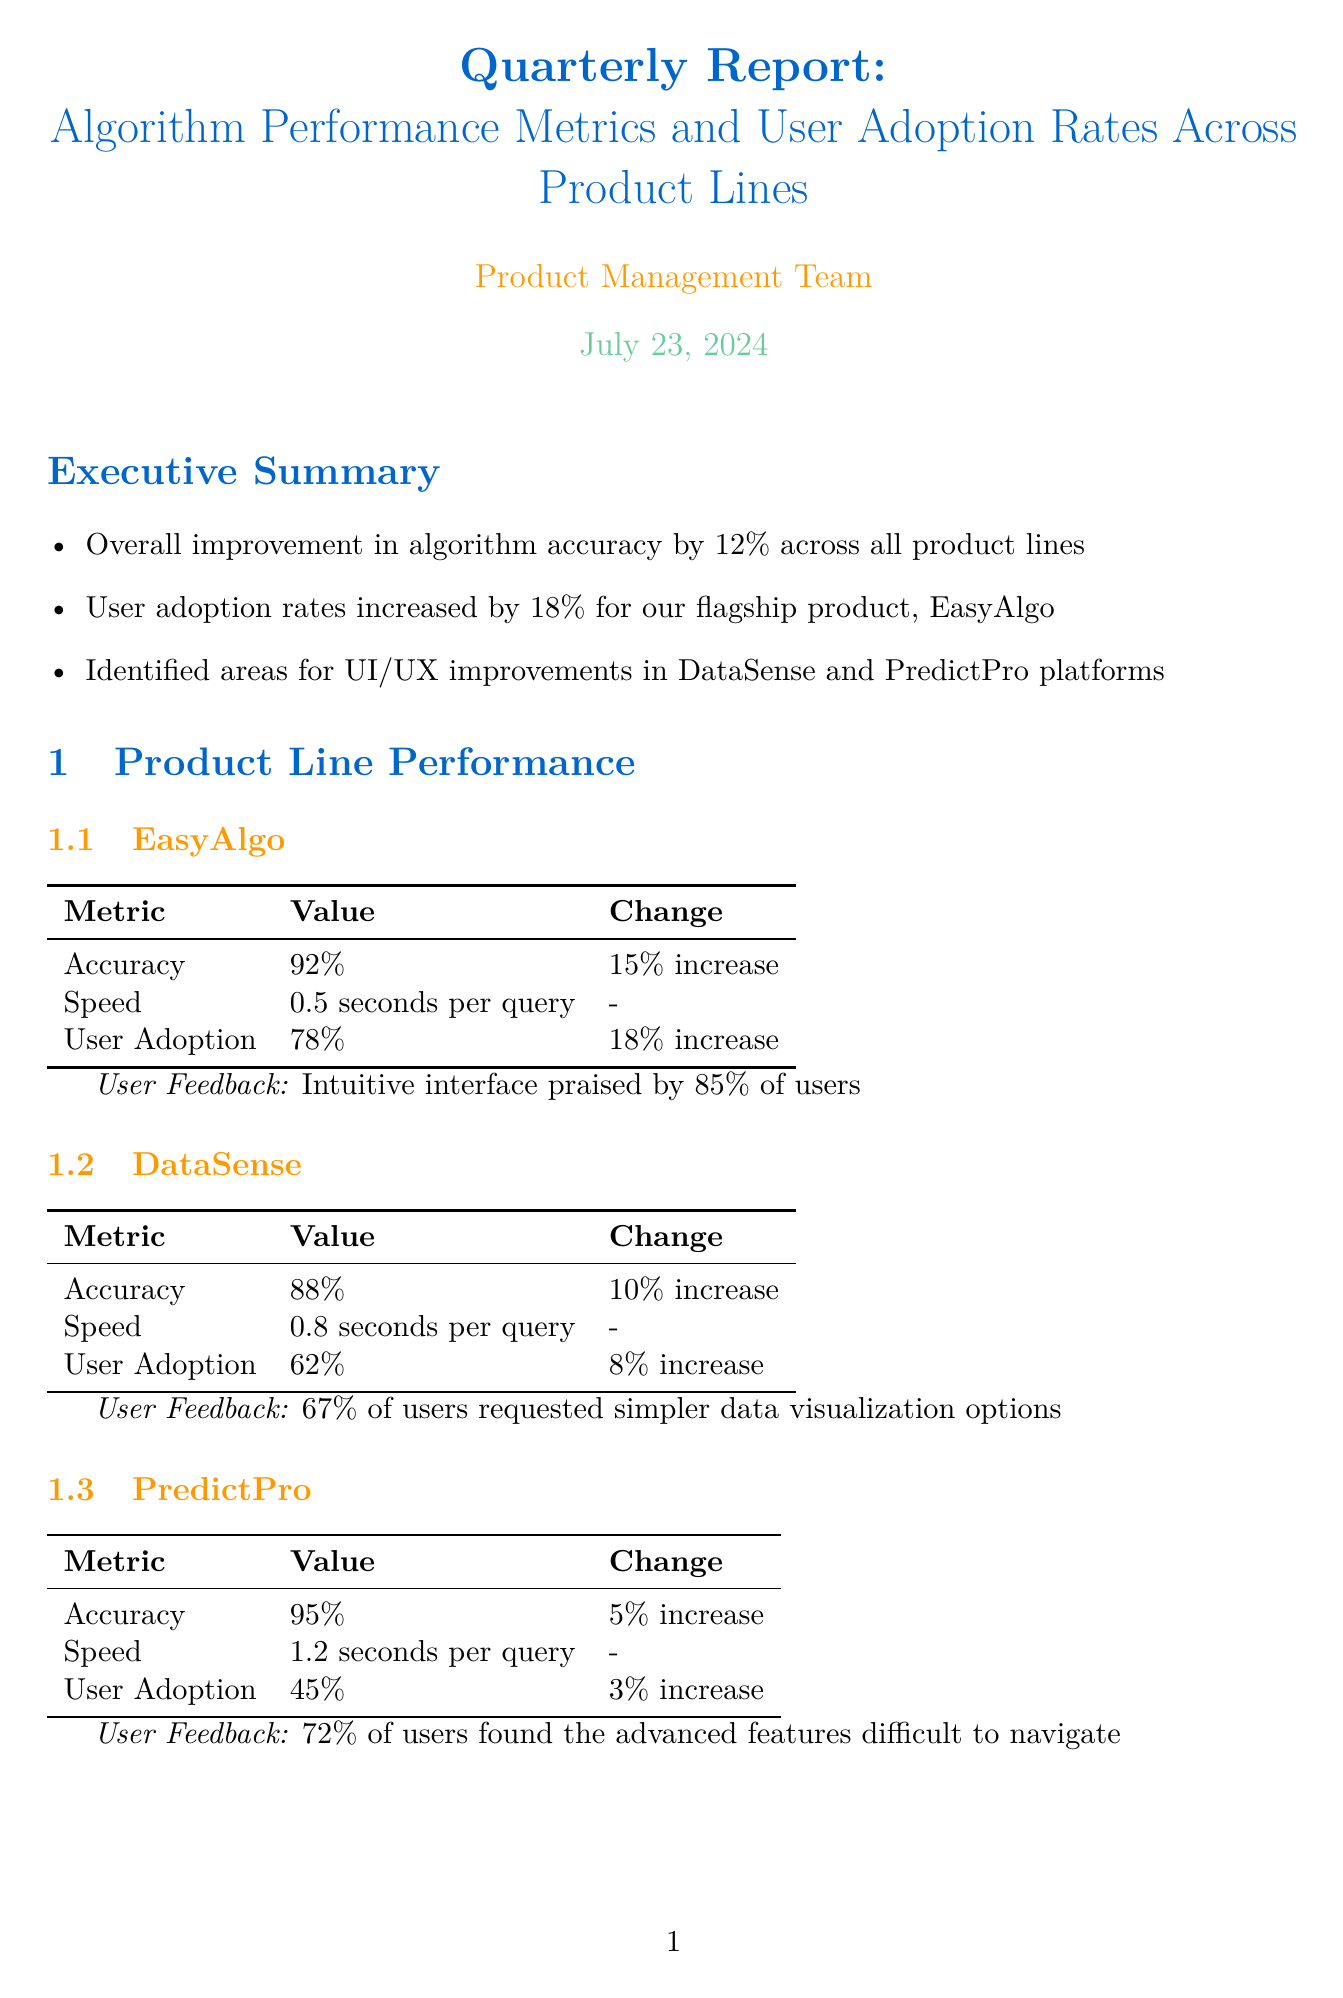What is the accuracy of EasyAlgo? The accuracy of EasyAlgo is stated as 92% in the algorithm performance section.
Answer: 92% What percentage of users praised EasyAlgo's intuitive interface? The document indicates that 85% of users praised EasyAlgo's intuitive interface in user feedback.
Answer: 85% What is the market share of our company? The report lists our company's market share as 35%, which is mentioned in the competitive analysis section.
Answer: 35% Which product had the highest user adoption rate? The document shows that EasyAlgo had the highest user adoption rate at 78% compared to other products.
Answer: EasyAlgo What percentage of users want more guidance on selecting algorithms? The document highlights that 65% of users want more guidance on selecting appropriate algorithms.
Answer: 65% What is a recommended improvement for PredictPro? The report suggests redesigning the algorithm configuration interface for better usability as an area for improvement for PredictPro.
Answer: Redesign the algorithm configuration interface for better usability Which product line was highlighted for an 18% increase in user adoption? The executive summary specifies that EasyAlgo experienced an 18% increase in user adoption rates.
Answer: EasyAlgo What is one of DataSense’s strengths? The document lists comprehensive data visualization tools as one of DataSense's strengths in the user interface analysis section.
Answer: Comprehensive data visualization tools What is the total number of respondents in the user surveys? The report states that there were a total of 1,500 respondents to the user surveys.
Answer: 1,500 